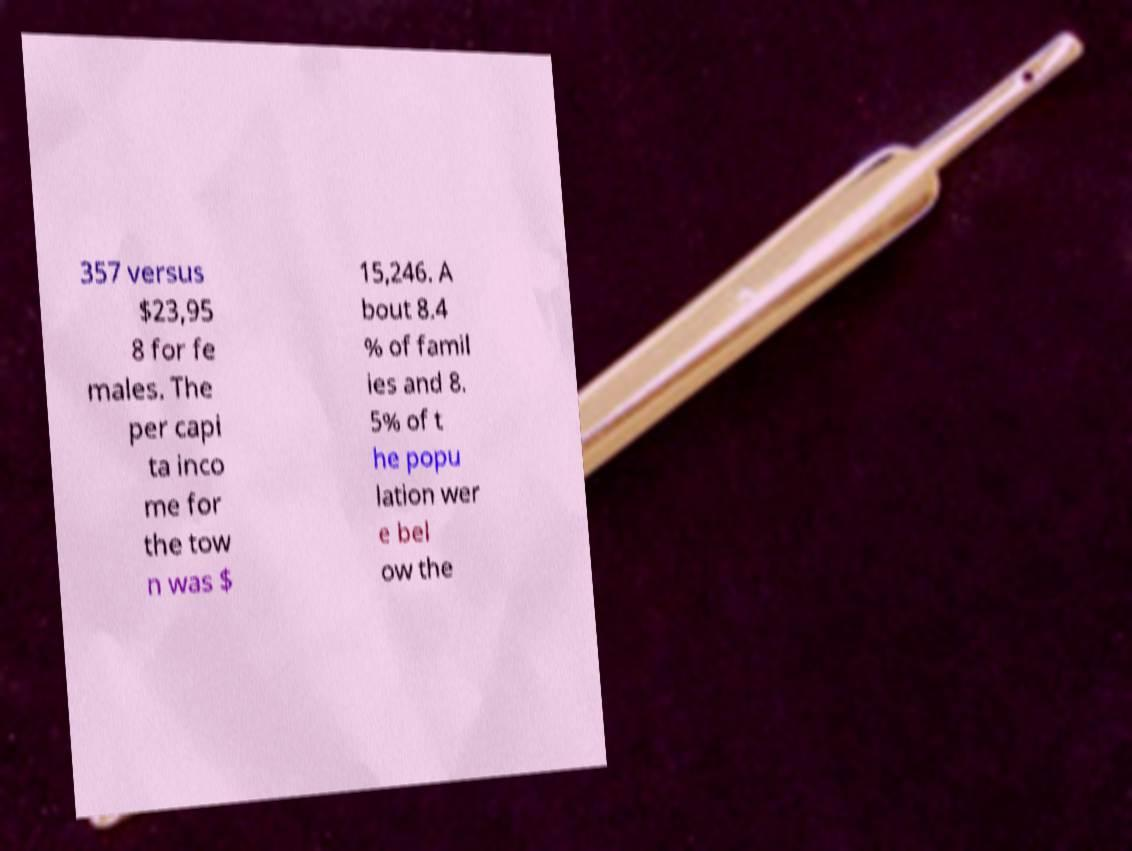What messages or text are displayed in this image? I need them in a readable, typed format. 357 versus $23,95 8 for fe males. The per capi ta inco me for the tow n was $ 15,246. A bout 8.4 % of famil ies and 8. 5% of t he popu lation wer e bel ow the 